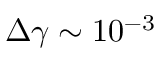<formula> <loc_0><loc_0><loc_500><loc_500>\Delta \gamma \sim 1 0 ^ { - 3 }</formula> 